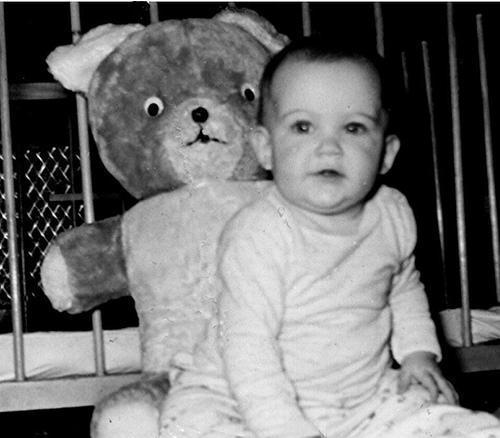How many kites are in the air?
Give a very brief answer. 0. 